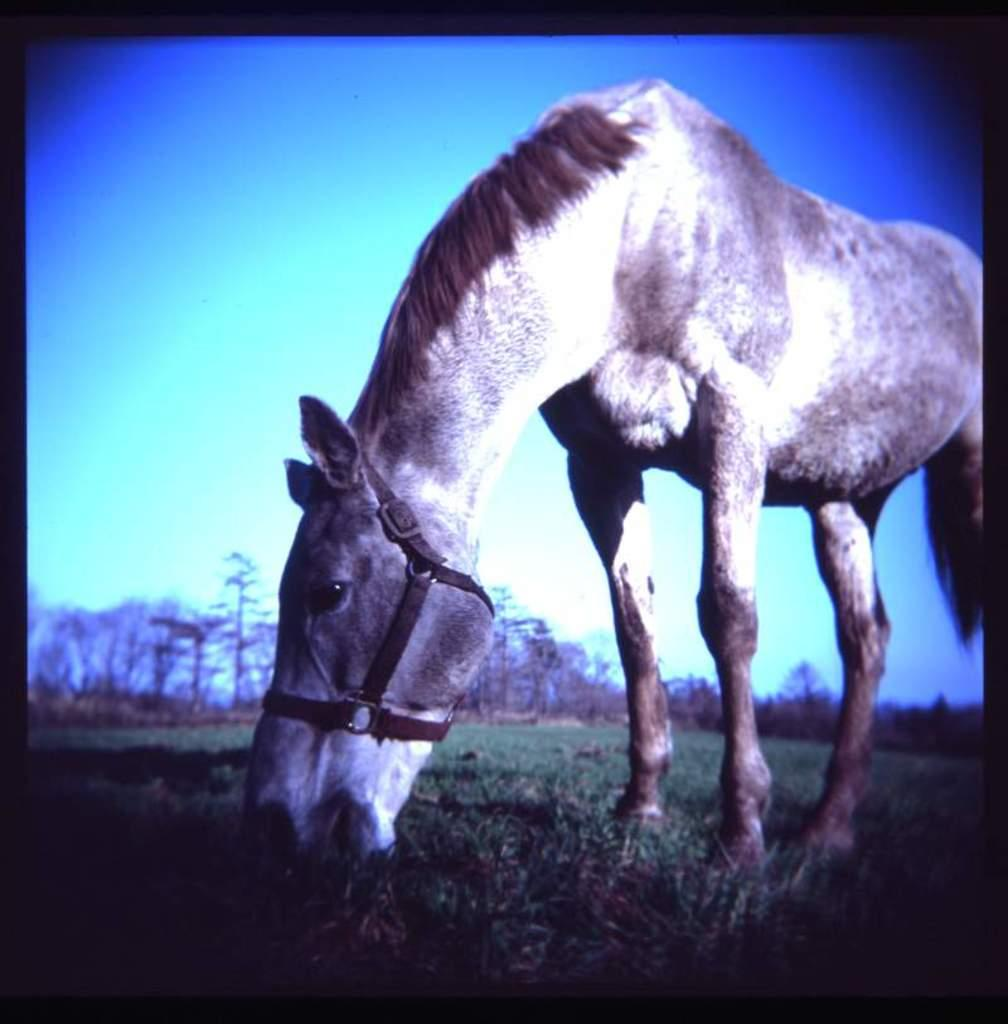What animal is present in the image? There is a horse in the image. What is the horse doing in the image? The horse is eating grass. What can be seen in the background of the image? There are trees and the sky visible in the background of the image. How is the image framed? The image has a black border. What type of cap is the horse wearing in the image? There is no cap present in the image; the horse is not wearing any clothing or accessories. 